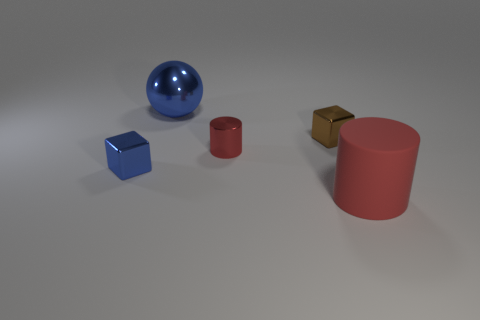Can you describe the colors and shapes of the objects in the image? Certainly! In the image, there are five distinct objects with different shapes and colors. Starting from the left, there is a small blue cube, followed by a shiny blue sphere, a small red cylinder, a textured golden cube, and finally on the far right, a large red cylinder. 